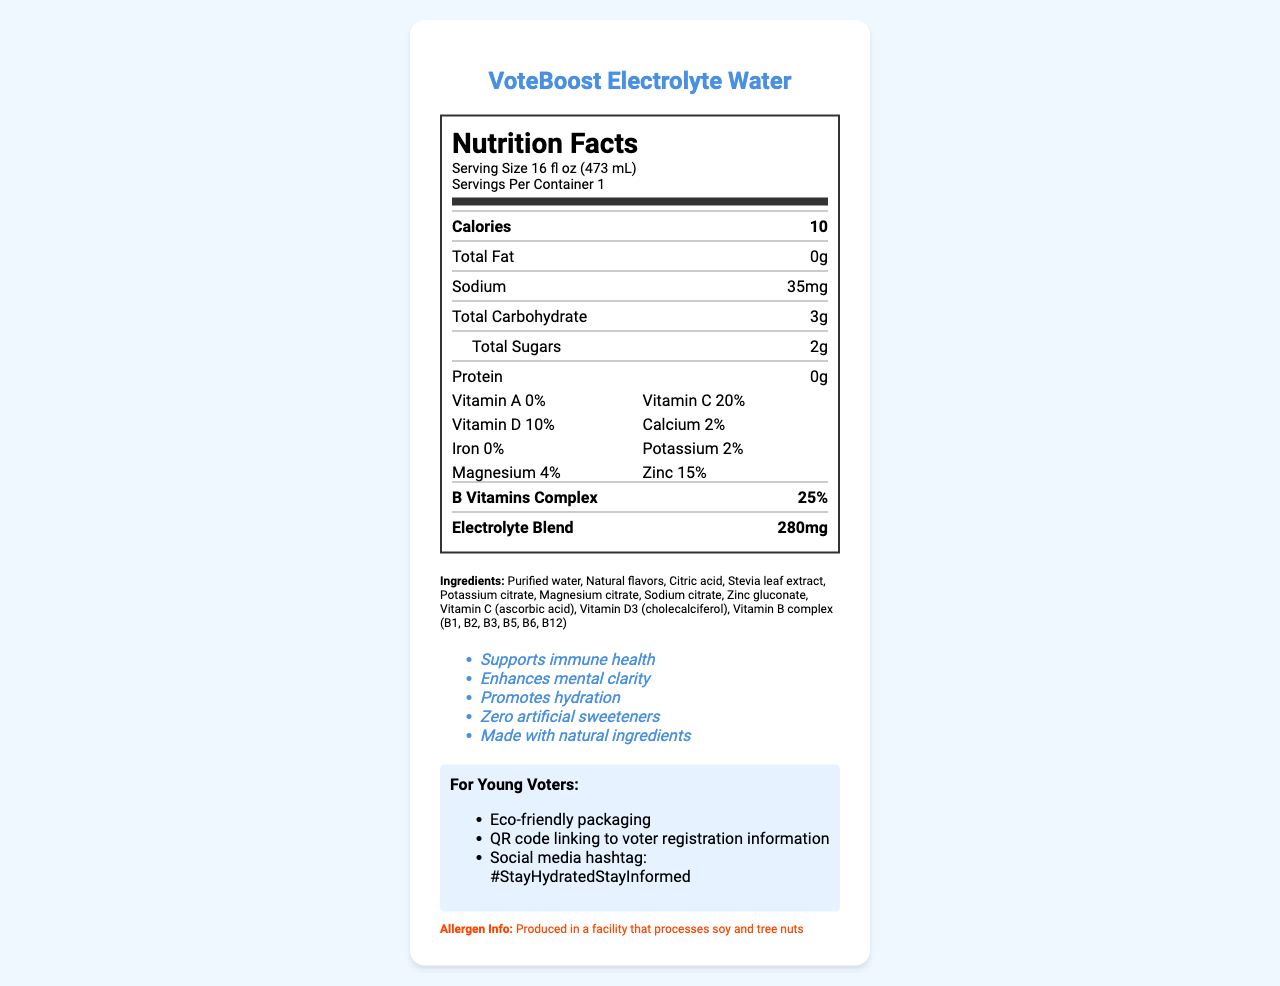what is the serving size for VoteBoost Electrolyte Water? The serving size is clearly listed at the top of the nutrition facts label as 16 fl oz (473 mL).
Answer: 16 fl oz (473 mL) what are the total calories per serving? The total calories per serving is listed directly under the serving size, showing as 10 calories.
Answer: 10 how much sodium is in one serving? The amount of sodium per serving is shown prominently in the nutrition facts as 35mg.
Answer: 35mg which vitamins are included in VoteBoost Electrolyte Water? The vitamins included are listed in the nutrition facts section: Vitamin C (20%), Vitamin D (10%), and B Vitamins Complex (25%).
Answer: Vitamin C, Vitamin D, B Vitamins Complex what is the allergen information for this product? The allergen information is mentioned clearly in the separate section at the bottom of the document.
Answer: Produced in a facility that processes soy and tree nuts which of the following is NOT a marketing claim for VoteBoost Electrolyte Water: A. Supports immune health B. Contains artificial sweeteners C. Enhances mental clarity D. Promotes hydration Contains artificial sweeteners is not a marketing claim. The product actually claims "Zero artificial sweeteners".
Answer: B how much total carbohydrates is in a serving of VoteBoost Electrolyte Water? A. 0g B. 10g C. 3g D. 5g Based on the nutrition facts, the Total Carbohydrate content is 3g per serving.
Answer: C is potassium listed as one of the electrolytes in the blend? Potassium is listed under both vitamins/minerals (2%) and is also part of the ingredients as Potassium Citrate.
Answer: Yes summarize the main information contained in the document about VoteBoost Electrolyte Water. The document highlights the nutritional content, marketing claims, and special features appealing to young voters while including important details like allergens and ingredient list.
Answer: VoteBoost Electrolyte Water provides hydration with a low calorie count of 10 per serving, along with essential electrolytes and vitamins (especially Vitamin C, D, B complex). It includes natural ingredients and avoids artificial sweeteners. It is also marketed towards young voters with eco-friendly packaging and voter registration resources. where can you purchase VoteBoost Electrolyte Water? The distribution details mention the product is available at college campuses and local health food stores.
Answer: Available at college campuses and local health food stores what is the website for more information on VoteBoost Electrolyte Water? The manufacturer's website is listed at the end of the document, providing more information.
Answer: www.voteboostwater.com does VoteBoost Electrolyte Water contain iron? The nutrition facts label shows that the iron content is listed as 0%.
Answer: No what minerals are present in VoteBoost Electrolyte Water? The minerals present are Calcium (2%), Potassium (2%), Magnesium (4%), and Zinc (15%), as listed in the nutrition facts.
Answer: Calcium, Potassium, Magnesium, Zinc why is the product particularly targeted towards young voters? This product targets young voters by leveraging eco-friendly values and providing resources that encourage voter participation.
Answer: It includes eco-friendly packaging, a QR code linking to voter registration information, and a social media hashtag #StayHydratedStayInformed. how many types of B vitamins are included in the Vitamin B complex? The document mentions "Vitamin B complex (B1, B2, B3, B5, B6, B12)" but doesn't specify how many types in total within the complex.
Answer: Cannot be determined 